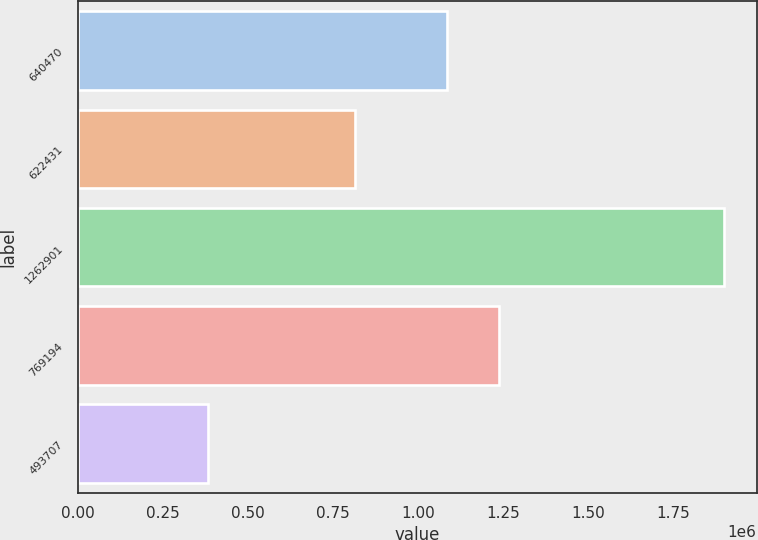Convert chart to OTSL. <chart><loc_0><loc_0><loc_500><loc_500><bar_chart><fcel>640470<fcel>622431<fcel>1262901<fcel>769194<fcel>493707<nl><fcel>1.08506e+06<fcel>814431<fcel>1.8995e+06<fcel>1.23674e+06<fcel>382774<nl></chart> 